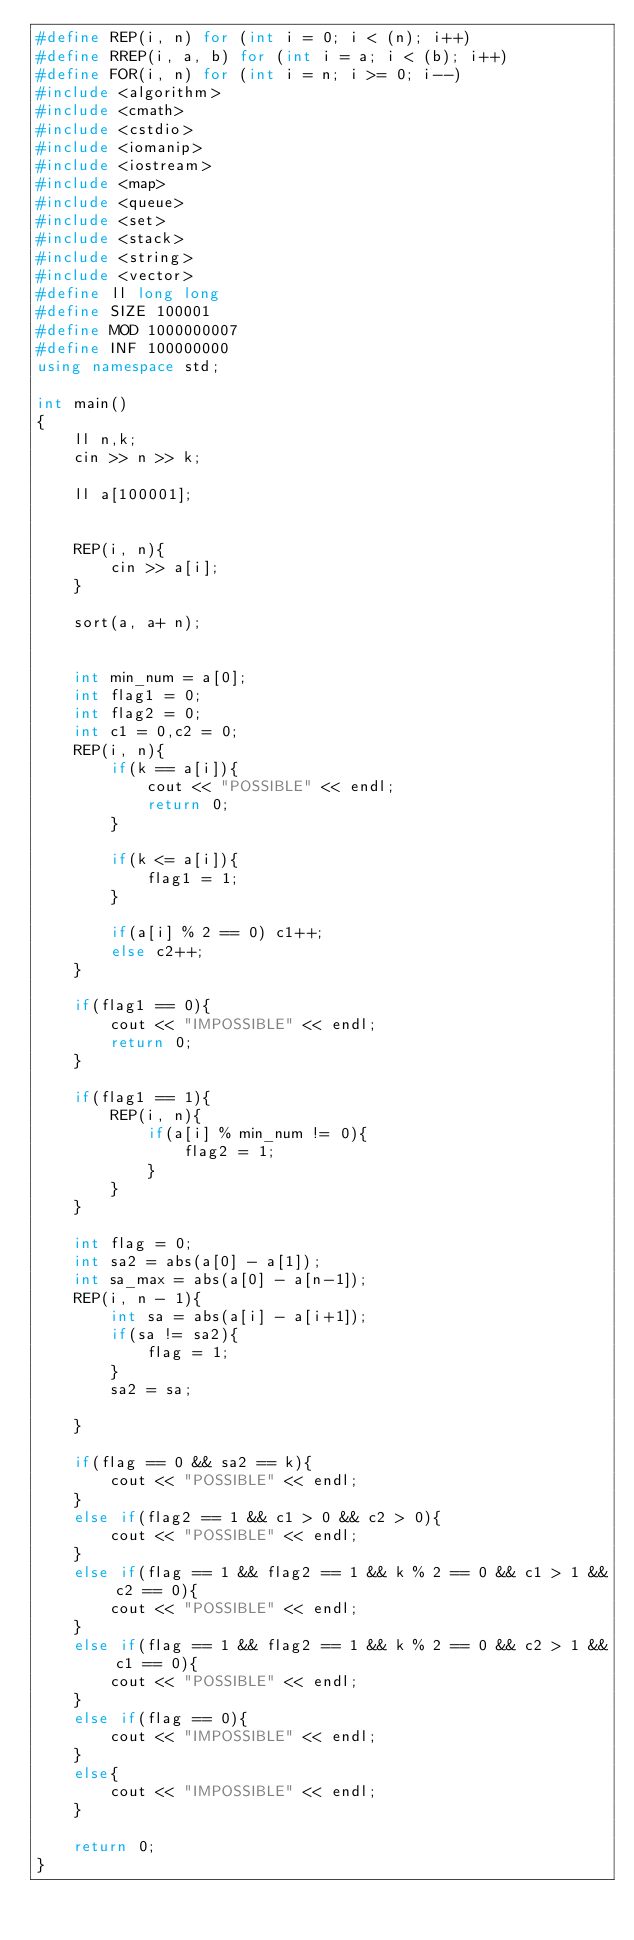Convert code to text. <code><loc_0><loc_0><loc_500><loc_500><_C++_>#define REP(i, n) for (int i = 0; i < (n); i++)
#define RREP(i, a, b) for (int i = a; i < (b); i++)
#define FOR(i, n) for (int i = n; i >= 0; i--)
#include <algorithm>
#include <cmath>
#include <cstdio>
#include <iomanip>
#include <iostream>
#include <map>
#include <queue>
#include <set>
#include <stack>
#include <string>
#include <vector>
#define ll long long
#define SIZE 100001
#define MOD 1000000007
#define INF 100000000
using namespace std;

int main()
{
    ll n,k;
    cin >> n >> k;

    ll a[100001];


    REP(i, n){
        cin >> a[i];
    }

    sort(a, a+ n);
    
    
    int min_num = a[0];
    int flag1 = 0;
    int flag2 = 0; 
    int c1 = 0,c2 = 0;
    REP(i, n){
        if(k == a[i]){
            cout << "POSSIBLE" << endl;
            return 0;
        }

        if(k <= a[i]){
            flag1 = 1;
        }

        if(a[i] % 2 == 0) c1++;
        else c2++;
    }

    if(flag1 == 0){
        cout << "IMPOSSIBLE" << endl;
        return 0;
    }

    if(flag1 == 1){
        REP(i, n){
            if(a[i] % min_num != 0){
                flag2 = 1;
            }
        }
    }

    int flag = 0;
    int sa2 = abs(a[0] - a[1]);
    int sa_max = abs(a[0] - a[n-1]);
    REP(i, n - 1){
        int sa = abs(a[i] - a[i+1]);
        if(sa != sa2){
            flag = 1;
        }
        sa2 = sa;

    }

    if(flag == 0 && sa2 == k){
        cout << "POSSIBLE" << endl;
    }
    else if(flag2 == 1 && c1 > 0 && c2 > 0){
        cout << "POSSIBLE" << endl;
    }
    else if(flag == 1 && flag2 == 1 && k % 2 == 0 && c1 > 1 && c2 == 0){
        cout << "POSSIBLE" << endl;
    }
    else if(flag == 1 && flag2 == 1 && k % 2 == 0 && c2 > 1 && c1 == 0){
        cout << "POSSIBLE" << endl;
    }
    else if(flag == 0){
        cout << "IMPOSSIBLE" << endl;
    }
    else{
        cout << "IMPOSSIBLE" << endl;
    }

    return 0;
}</code> 